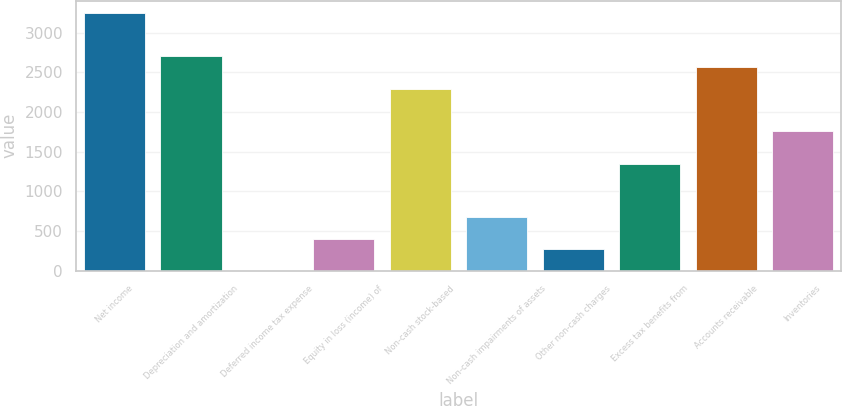Convert chart to OTSL. <chart><loc_0><loc_0><loc_500><loc_500><bar_chart><fcel>Net income<fcel>Depreciation and amortization<fcel>Deferred income tax expense<fcel>Equity in loss (income) of<fcel>Non-cash stock-based<fcel>Non-cash impairments of assets<fcel>Other non-cash charges<fcel>Excess tax benefits from<fcel>Accounts receivable<fcel>Inventories<nl><fcel>3241.88<fcel>2701.6<fcel>0.2<fcel>405.41<fcel>2296.39<fcel>675.55<fcel>270.34<fcel>1350.9<fcel>2566.53<fcel>1756.11<nl></chart> 